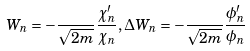<formula> <loc_0><loc_0><loc_500><loc_500>W _ { n } = - \frac { } { \sqrt { 2 m } } \frac { \chi ^ { \prime } _ { n } } { \chi _ { n } } , \Delta W _ { n } = - \frac { } { \sqrt { 2 m } } \frac { \phi ^ { \prime } _ { n } } { \phi _ { n } }</formula> 